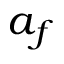<formula> <loc_0><loc_0><loc_500><loc_500>a _ { f }</formula> 